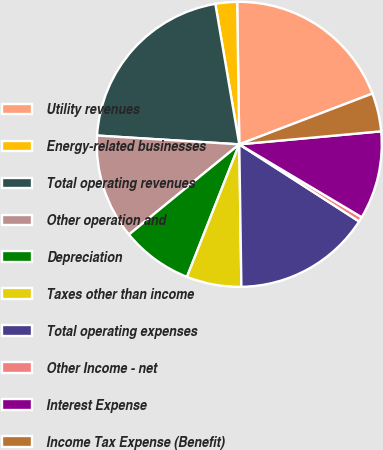<chart> <loc_0><loc_0><loc_500><loc_500><pie_chart><fcel>Utility revenues<fcel>Energy-related businesses<fcel>Total operating revenues<fcel>Other operation and<fcel>Depreciation<fcel>Taxes other than income<fcel>Total operating expenses<fcel>Other Income - net<fcel>Interest Expense<fcel>Income Tax Expense (Benefit)<nl><fcel>19.44%<fcel>2.45%<fcel>21.33%<fcel>11.89%<fcel>8.11%<fcel>6.22%<fcel>15.66%<fcel>0.56%<fcel>10.0%<fcel>4.34%<nl></chart> 